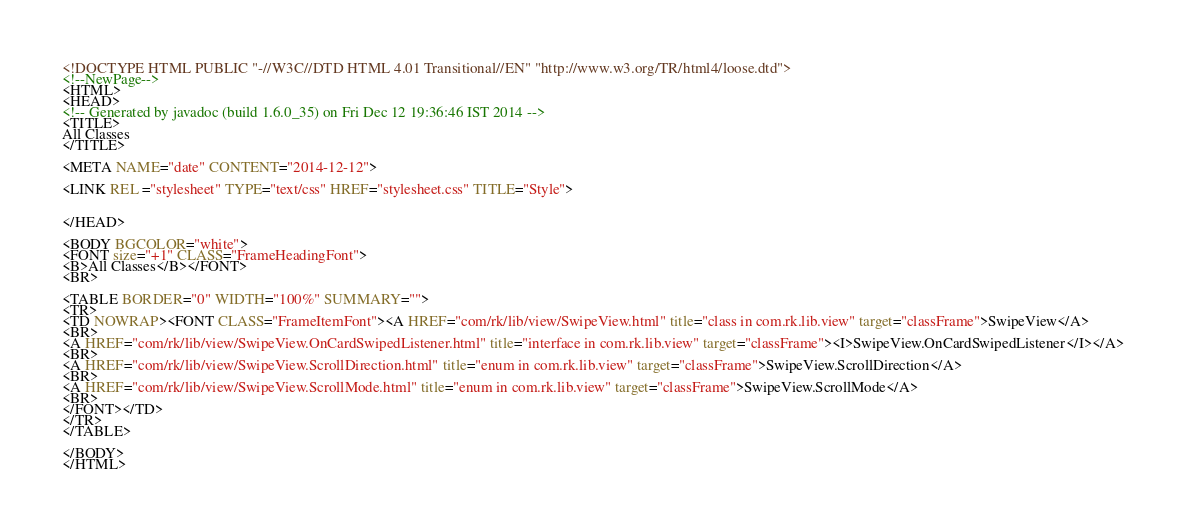Convert code to text. <code><loc_0><loc_0><loc_500><loc_500><_HTML_><!DOCTYPE HTML PUBLIC "-//W3C//DTD HTML 4.01 Transitional//EN" "http://www.w3.org/TR/html4/loose.dtd">
<!--NewPage-->
<HTML>
<HEAD>
<!-- Generated by javadoc (build 1.6.0_35) on Fri Dec 12 19:36:46 IST 2014 -->
<TITLE>
All Classes
</TITLE>

<META NAME="date" CONTENT="2014-12-12">

<LINK REL ="stylesheet" TYPE="text/css" HREF="stylesheet.css" TITLE="Style">


</HEAD>

<BODY BGCOLOR="white">
<FONT size="+1" CLASS="FrameHeadingFont">
<B>All Classes</B></FONT>
<BR>

<TABLE BORDER="0" WIDTH="100%" SUMMARY="">
<TR>
<TD NOWRAP><FONT CLASS="FrameItemFont"><A HREF="com/rk/lib/view/SwipeView.html" title="class in com.rk.lib.view" target="classFrame">SwipeView</A>
<BR>
<A HREF="com/rk/lib/view/SwipeView.OnCardSwipedListener.html" title="interface in com.rk.lib.view" target="classFrame"><I>SwipeView.OnCardSwipedListener</I></A>
<BR>
<A HREF="com/rk/lib/view/SwipeView.ScrollDirection.html" title="enum in com.rk.lib.view" target="classFrame">SwipeView.ScrollDirection</A>
<BR>
<A HREF="com/rk/lib/view/SwipeView.ScrollMode.html" title="enum in com.rk.lib.view" target="classFrame">SwipeView.ScrollMode</A>
<BR>
</FONT></TD>
</TR>
</TABLE>

</BODY>
</HTML>
</code> 